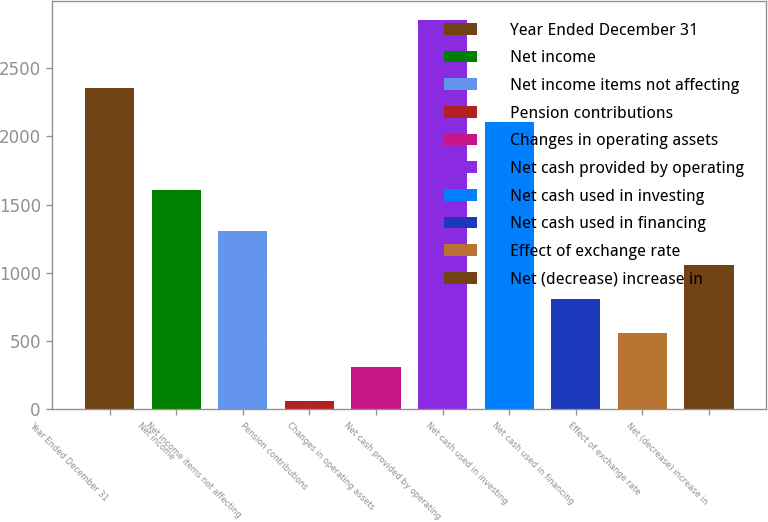Convert chart to OTSL. <chart><loc_0><loc_0><loc_500><loc_500><bar_chart><fcel>Year Ended December 31<fcel>Net income<fcel>Net income items not affecting<fcel>Pension contributions<fcel>Changes in operating assets<fcel>Net cash provided by operating<fcel>Net cash used in investing<fcel>Net cash used in financing<fcel>Effect of exchange rate<fcel>Net (decrease) increase in<nl><fcel>2351.93<fcel>1604<fcel>1309.45<fcel>62.9<fcel>312.21<fcel>2850.55<fcel>2102.62<fcel>810.83<fcel>561.52<fcel>1060.14<nl></chart> 